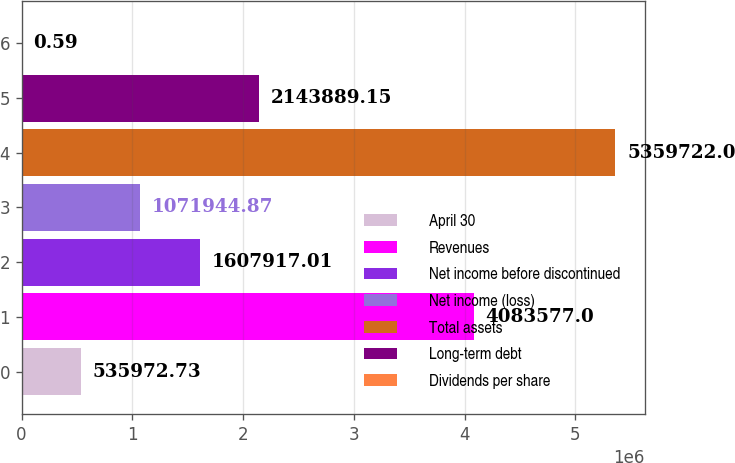Convert chart to OTSL. <chart><loc_0><loc_0><loc_500><loc_500><bar_chart><fcel>April 30<fcel>Revenues<fcel>Net income before discontinued<fcel>Net income (loss)<fcel>Total assets<fcel>Long-term debt<fcel>Dividends per share<nl><fcel>535973<fcel>4.08358e+06<fcel>1.60792e+06<fcel>1.07194e+06<fcel>5.35972e+06<fcel>2.14389e+06<fcel>0.59<nl></chart> 